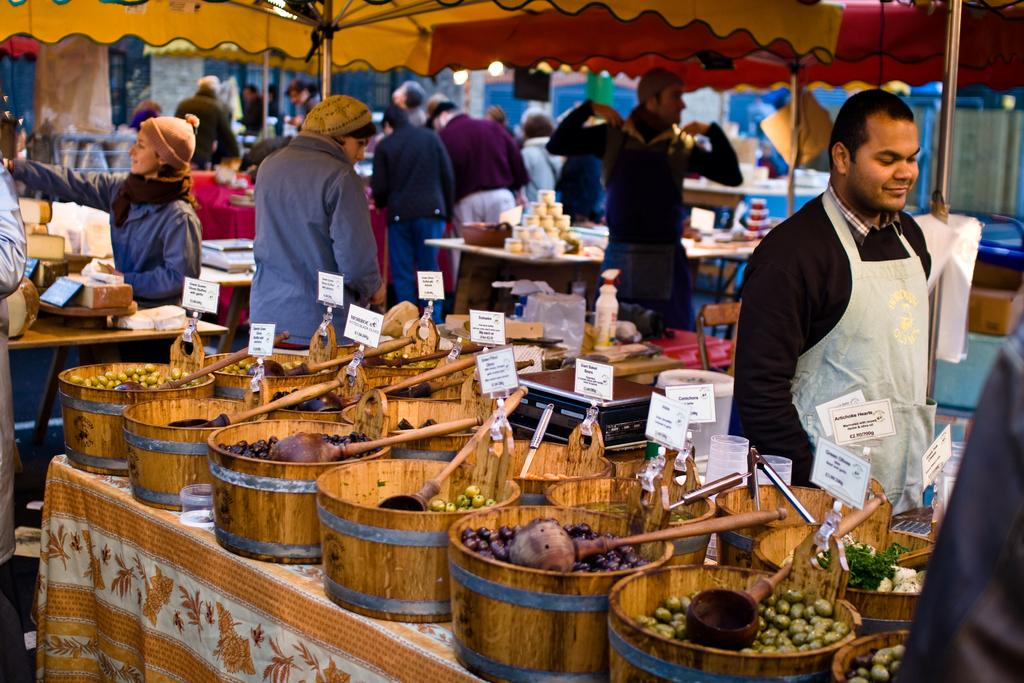What is on the table in the image? There are food items in bowls, tents, and lights present on the table in the image. Are there any people in the image? Yes, there are persons present at the table. What might be used to illuminate the area in the image? Lights are present on the table, which might be used to illuminate the area. How much salt is present on the table in the image? There is no salt mentioned or visible in the image. Can you tell me how many people are asking for help in the image? There is no indication of anyone asking for help in the image. 